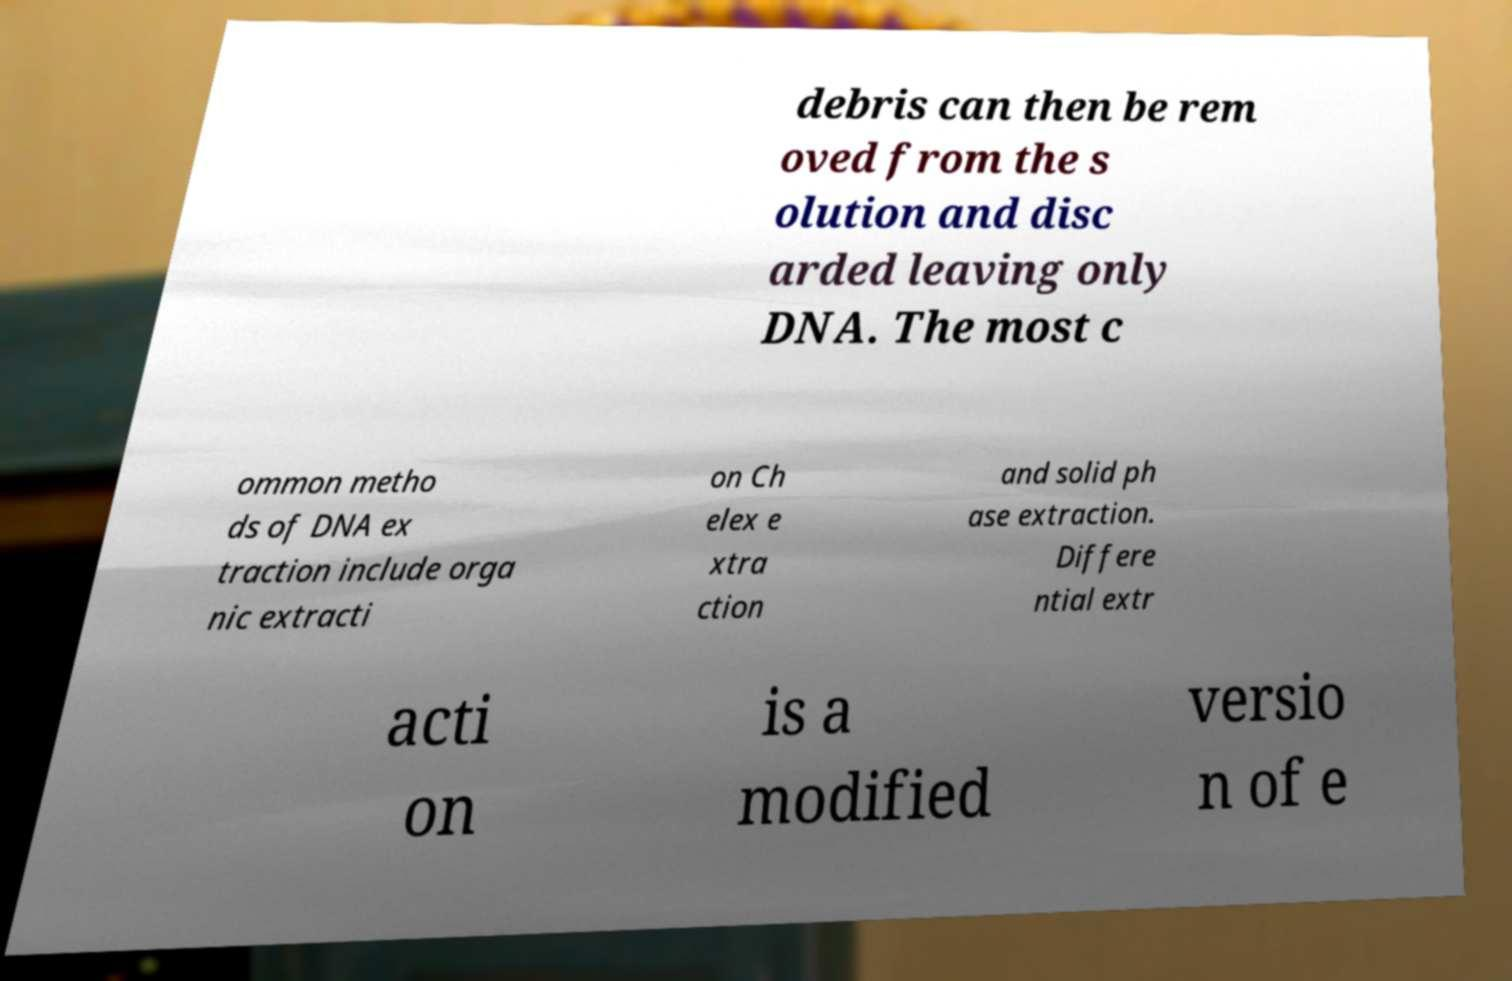Can you accurately transcribe the text from the provided image for me? debris can then be rem oved from the s olution and disc arded leaving only DNA. The most c ommon metho ds of DNA ex traction include orga nic extracti on Ch elex e xtra ction and solid ph ase extraction. Differe ntial extr acti on is a modified versio n of e 